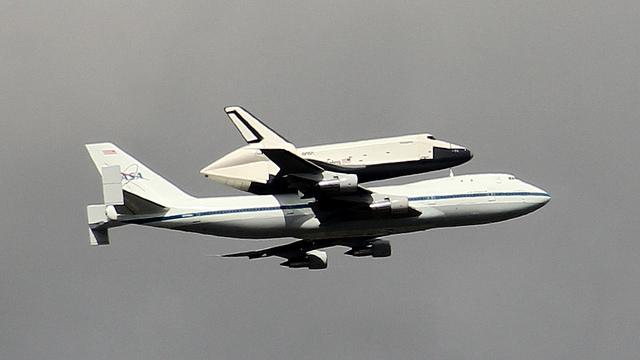What color is the sky?
Quick response, please. Gray. Are the two planes going to the same place?
Give a very brief answer. Yes. What is red on the big plane?
Short answer required. Flag. Are the planes on the ground?
Be succinct. No. 